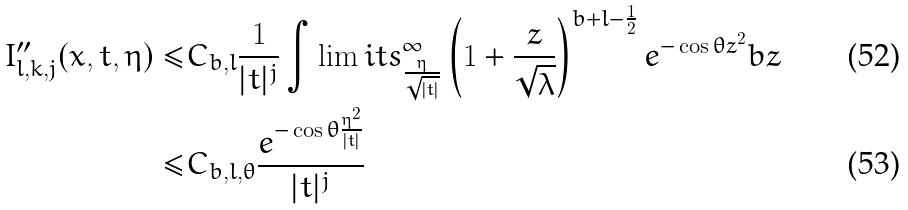<formula> <loc_0><loc_0><loc_500><loc_500>I _ { l , k , j } ^ { \prime \prime } ( x , t , \eta ) \leq & C _ { b , l } \frac { 1 } { | t | ^ { j } } \int \lim i t s _ { \frac { \eta } { \sqrt { | t | } } } ^ { \infty } \left ( 1 + \frac { z } { \sqrt { \lambda } } \right ) ^ { b + l - \frac { 1 } { 2 } } e ^ { - \cos \theta z ^ { 2 } } b z \\ \leq & C _ { b , l , \theta } \frac { e ^ { - \cos \theta \frac { \eta ^ { 2 } } { | t | } } } { | t | ^ { j } }</formula> 